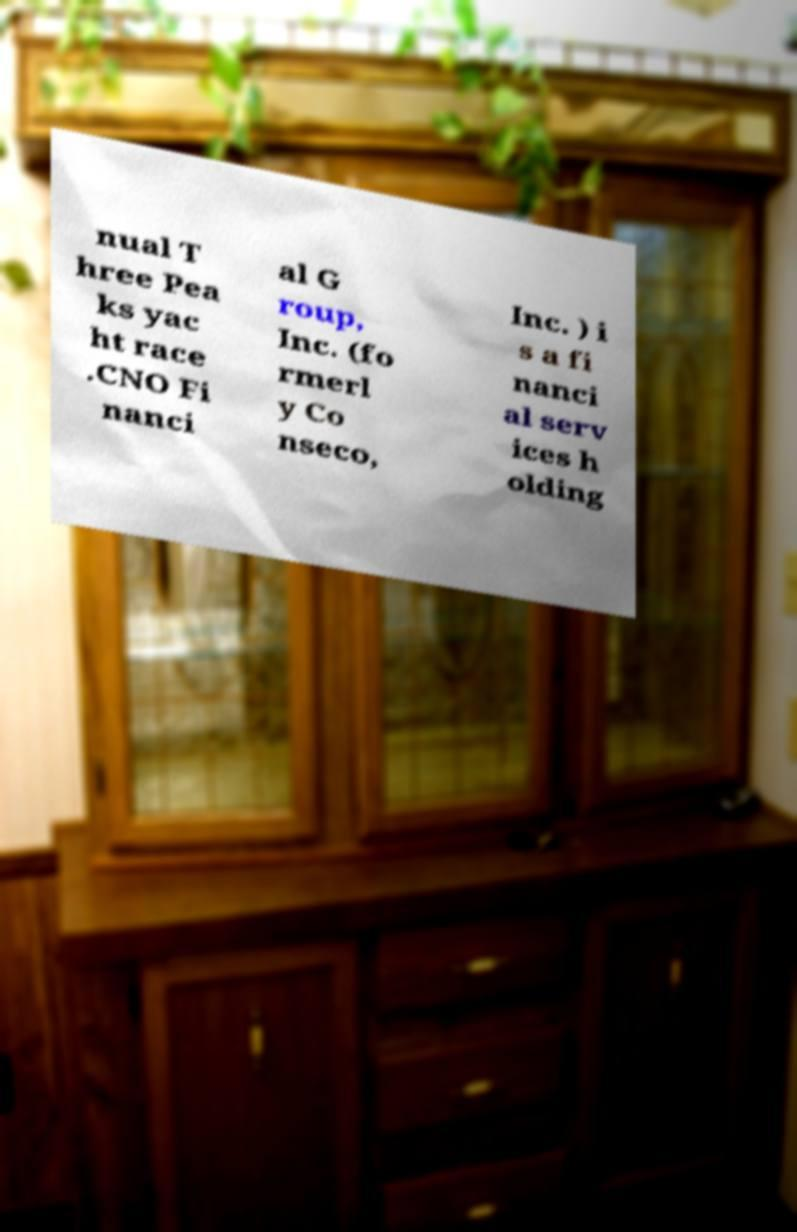Can you read and provide the text displayed in the image?This photo seems to have some interesting text. Can you extract and type it out for me? nual T hree Pea ks yac ht race .CNO Fi nanci al G roup, Inc. (fo rmerl y Co nseco, Inc. ) i s a fi nanci al serv ices h olding 